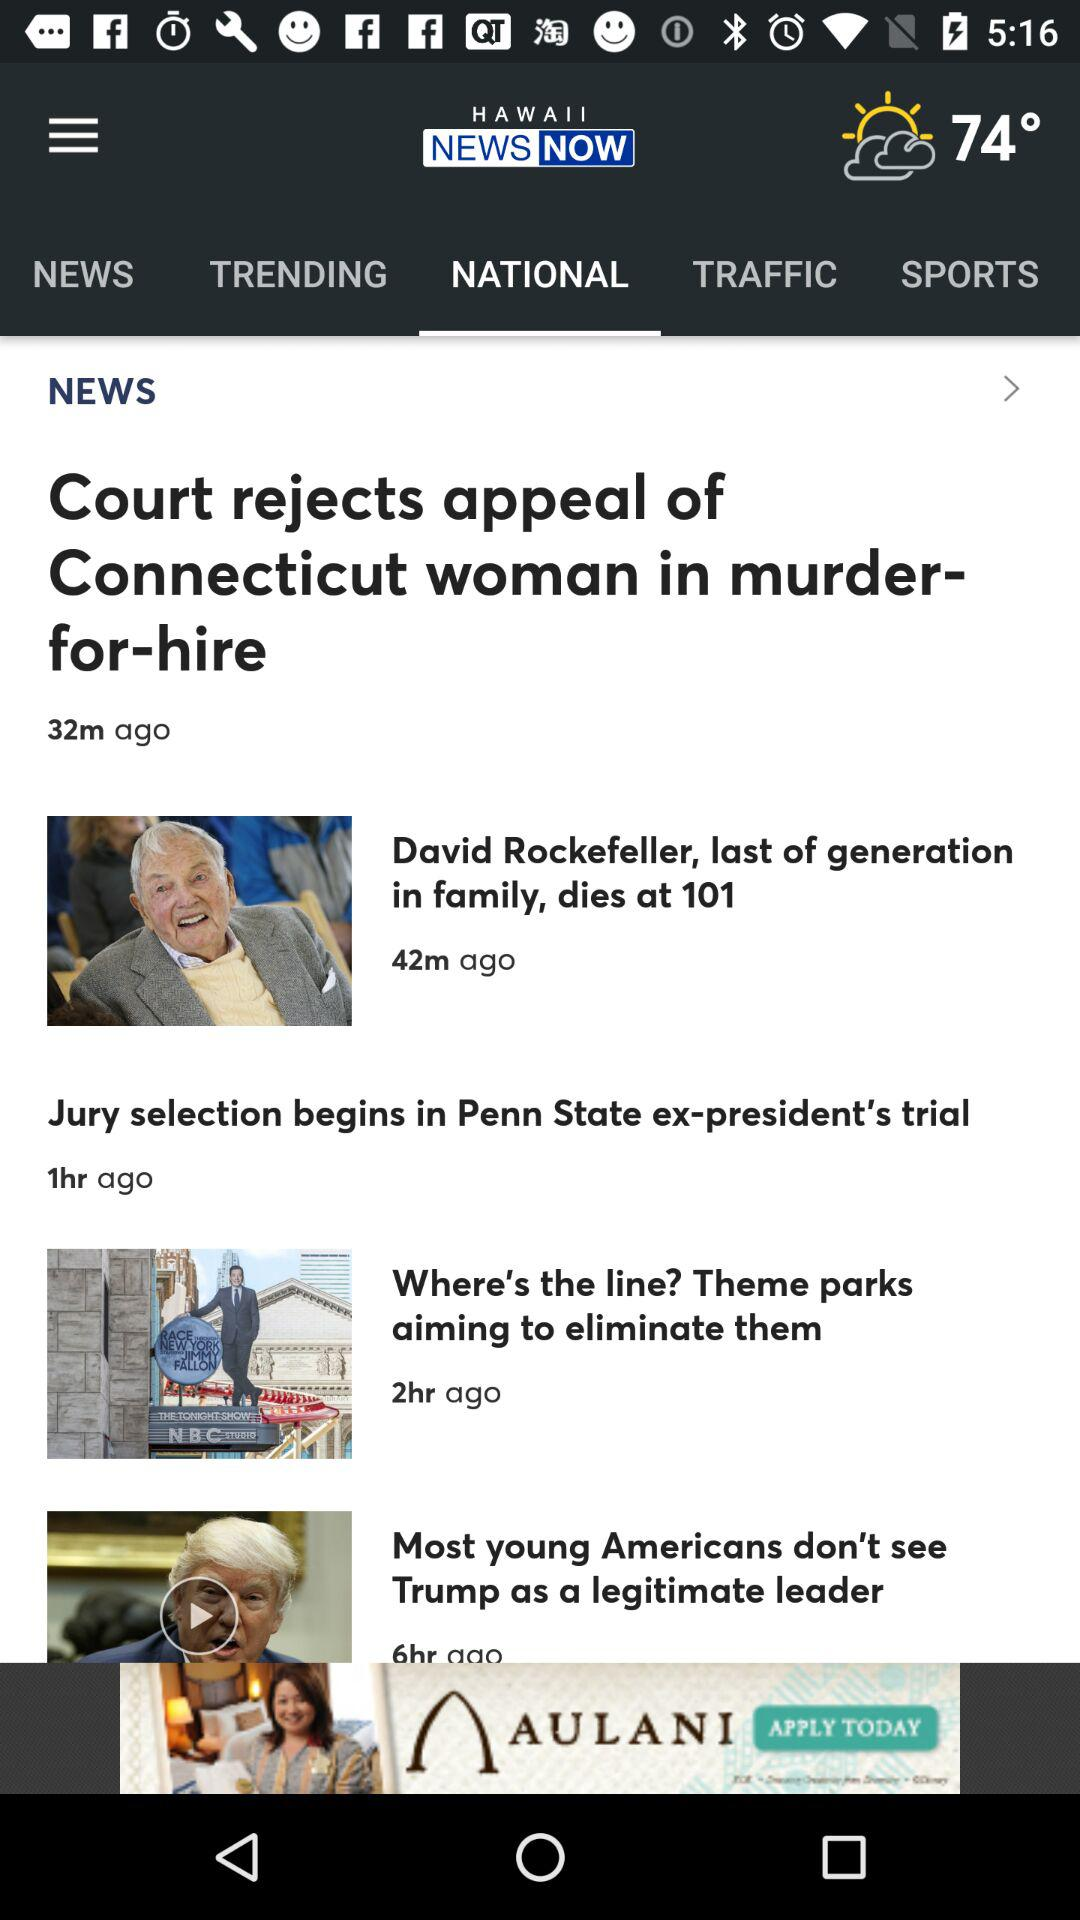Which tab is selected? The selected tab is "NATIONAL". 